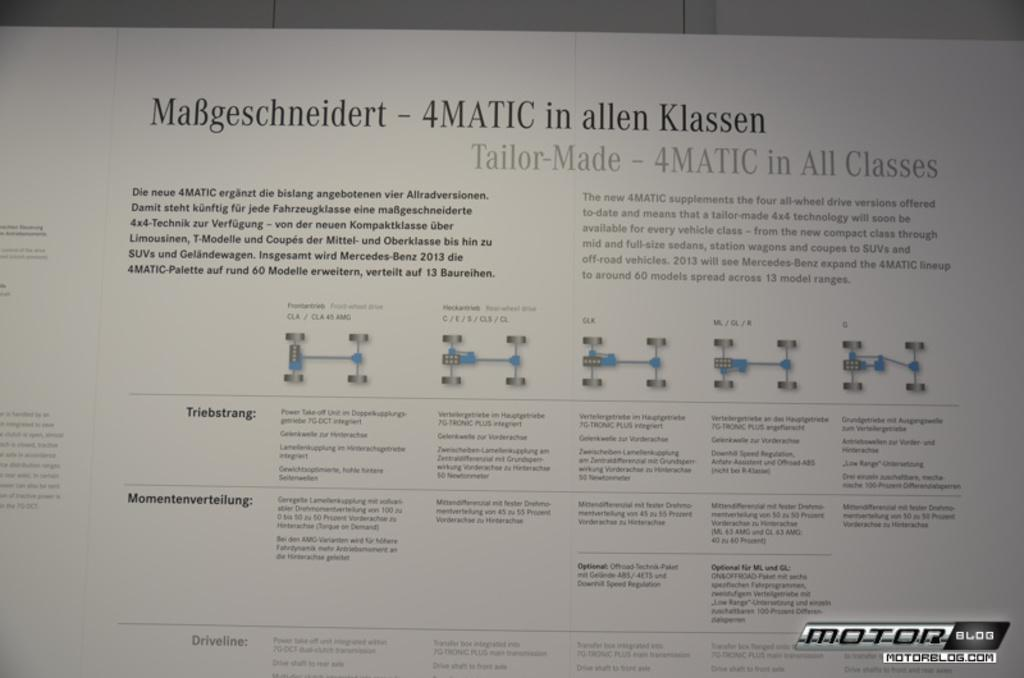<image>
Share a concise interpretation of the image provided. 4matic instructions and pictures page on motorblog.com site 